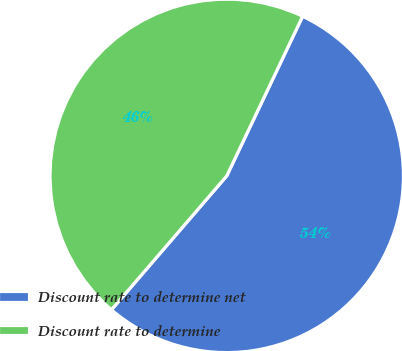<chart> <loc_0><loc_0><loc_500><loc_500><pie_chart><fcel>Discount rate to determine net<fcel>Discount rate to determine<nl><fcel>54.25%<fcel>45.75%<nl></chart> 